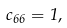<formula> <loc_0><loc_0><loc_500><loc_500>c _ { 6 6 } = 1 ,</formula> 